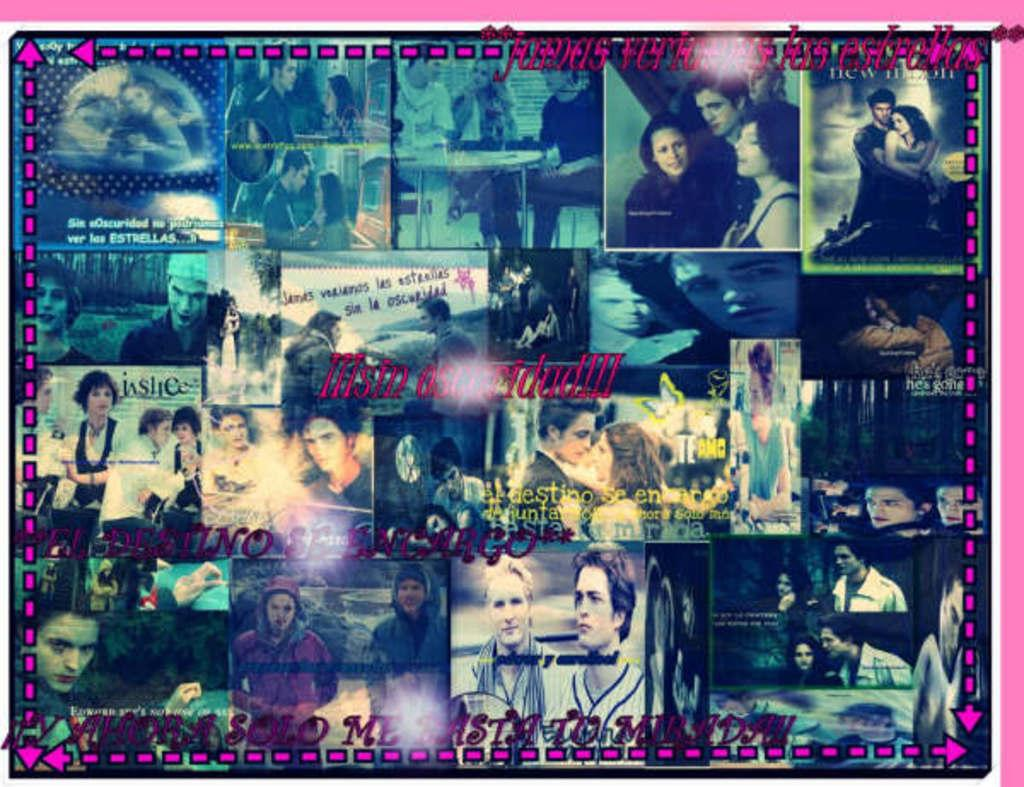What type of image is being described? The image is a collage of different pictures. What shape is the porter carrying in the image? There is no porter present in the image, and therefore no shape can be identified. 